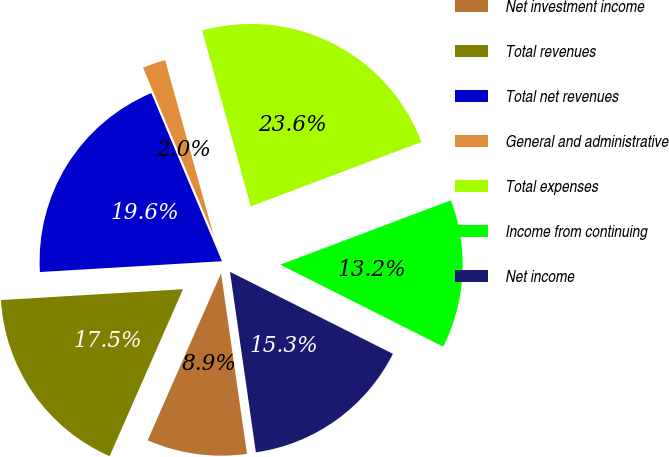Convert chart to OTSL. <chart><loc_0><loc_0><loc_500><loc_500><pie_chart><fcel>Net investment income<fcel>Total revenues<fcel>Total net revenues<fcel>General and administrative<fcel>Total expenses<fcel>Income from continuing<fcel>Net income<nl><fcel>8.86%<fcel>17.46%<fcel>19.61%<fcel>2.04%<fcel>23.55%<fcel>13.16%<fcel>15.31%<nl></chart> 